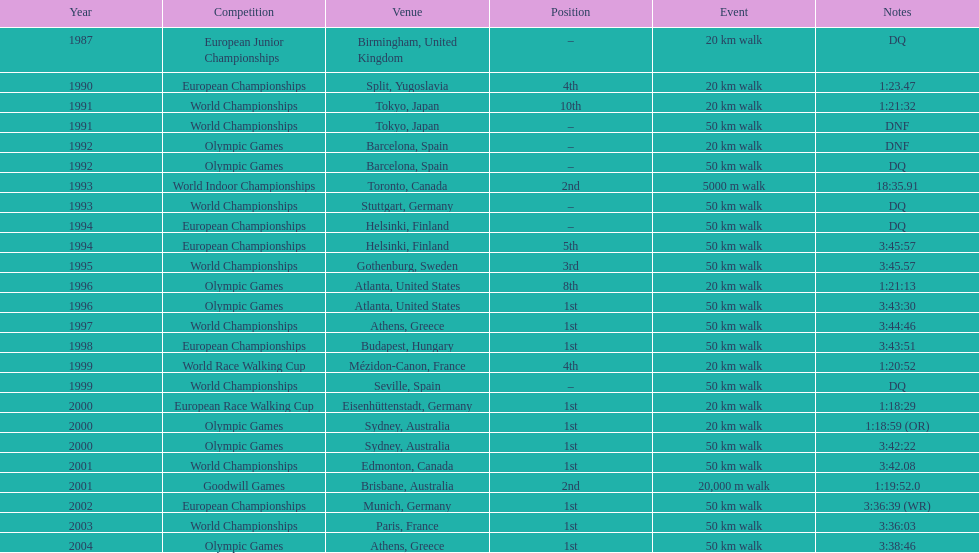How many events were at least 50 km? 17. 